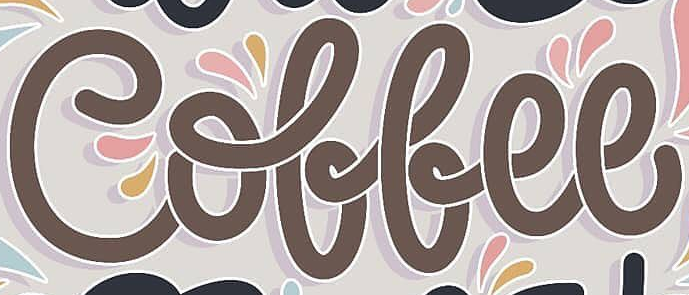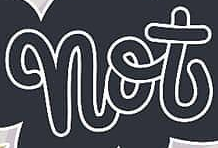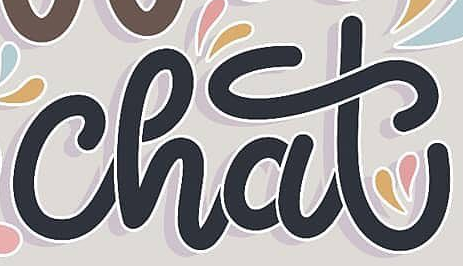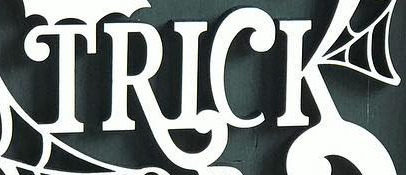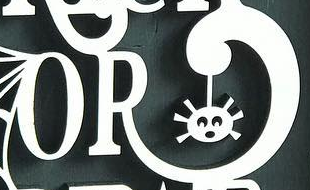What text appears in these images from left to right, separated by a semicolon? Coffee; not; chat; TRICK; OR 